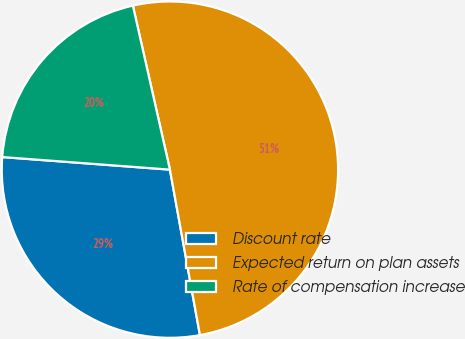Convert chart. <chart><loc_0><loc_0><loc_500><loc_500><pie_chart><fcel>Discount rate<fcel>Expected return on plan assets<fcel>Rate of compensation increase<nl><fcel>29.05%<fcel>50.68%<fcel>20.27%<nl></chart> 